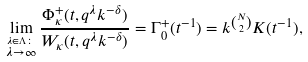Convert formula to latex. <formula><loc_0><loc_0><loc_500><loc_500>\lim _ { \stackrel { \lambda \in \Lambda \colon } { \lambda \rightarrow \infty } } \frac { \Phi _ { \kappa } ^ { + } ( t , q ^ { \lambda } k ^ { - \delta } ) } { W _ { \kappa } ( t , q ^ { \lambda } k ^ { - \delta } ) } = \Gamma _ { 0 } ^ { + } ( t ^ { - 1 } ) = k ^ { N \choose 2 } K ( t ^ { - 1 } ) ,</formula> 